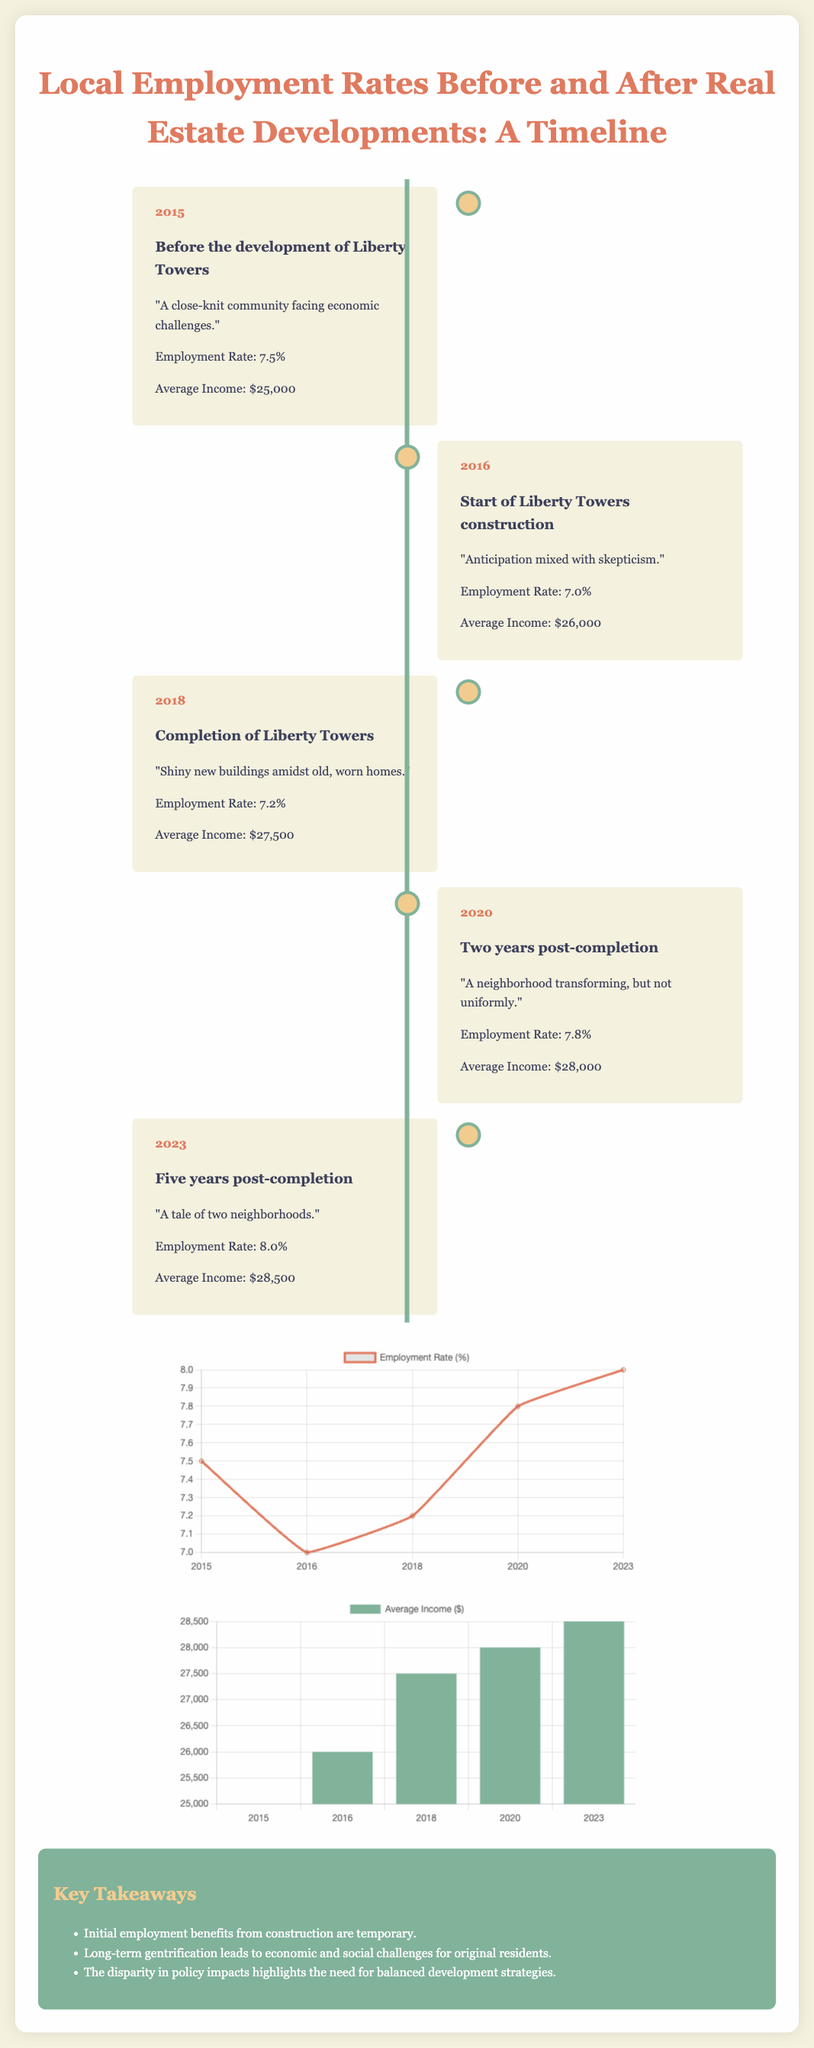what was the employment rate in 2015? The employment rate in 2015 is stated in the document, which shows it as 7.5%.
Answer: 7.5% what happened in 2016? The document describes the year 2016 as the start of Liberty Towers construction.
Answer: Start of Liberty Towers construction what is the average income in 2023? The average income for 2023 is provided in the document, which is $28,500.
Answer: $28,500 how did the employment rate change from 2015 to 2023? The employment rate increased from 7.5% in 2015 to 8.0% in 2023, showing an overall growth.
Answer: Increased by 0.5% what is highlighted in the key takeaways? The key takeaways include important notes on initial benefits and long-term challenges related to gentrification.
Answer: Initial employment benefits are temporary what does the timeline illustrate? The timeline illustrates the changes in employment rates and average income before and after real estate developments, providing a chronological view.
Answer: Changes in employment rates and average income what year marks the completion of Liberty Towers? The completion of Liberty Towers is mentioned to have occurred in 2018.
Answer: 2018 what type of chart represents employment rates? The type of chart used for employment rates is a line chart as shown in the document.
Answer: Line chart when did the employment rate peak in the timeline? The peak employment rate is indicated in the timeline as occurring in 2023.
Answer: 2023 